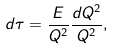Convert formula to latex. <formula><loc_0><loc_0><loc_500><loc_500>d \tau = \frac { E } { Q ^ { 2 } } \frac { d Q ^ { 2 } } { Q ^ { 2 } } ,</formula> 